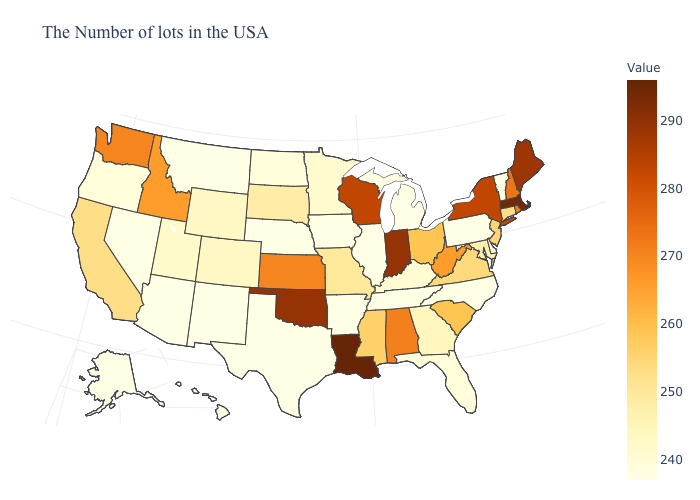Among the states that border Massachusetts , which have the highest value?
Quick response, please. New York. Does Louisiana have the highest value in the USA?
Answer briefly. Yes. Does Texas have the lowest value in the South?
Answer briefly. Yes. Is the legend a continuous bar?
Keep it brief. Yes. Does Texas have the highest value in the South?
Answer briefly. No. Does the map have missing data?
Concise answer only. No. 